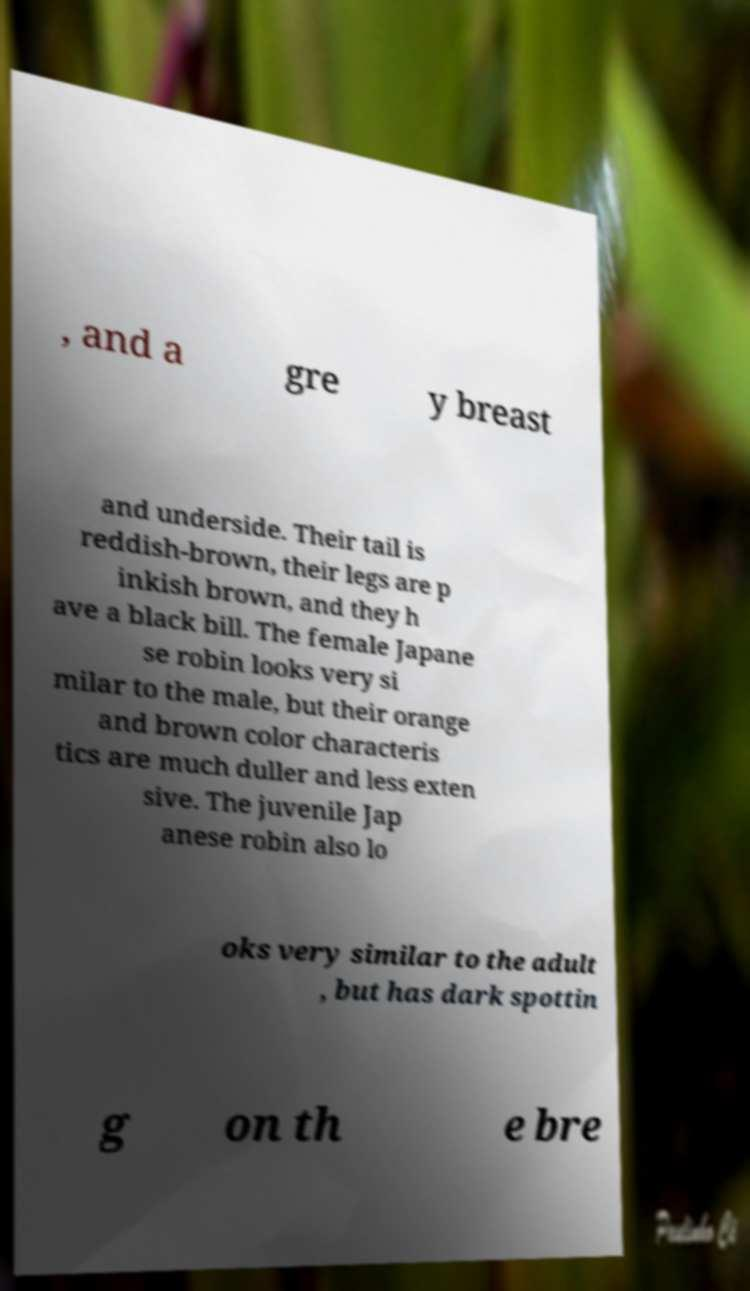There's text embedded in this image that I need extracted. Can you transcribe it verbatim? , and a gre y breast and underside. Their tail is reddish-brown, their legs are p inkish brown, and they h ave a black bill. The female Japane se robin looks very si milar to the male, but their orange and brown color characteris tics are much duller and less exten sive. The juvenile Jap anese robin also lo oks very similar to the adult , but has dark spottin g on th e bre 